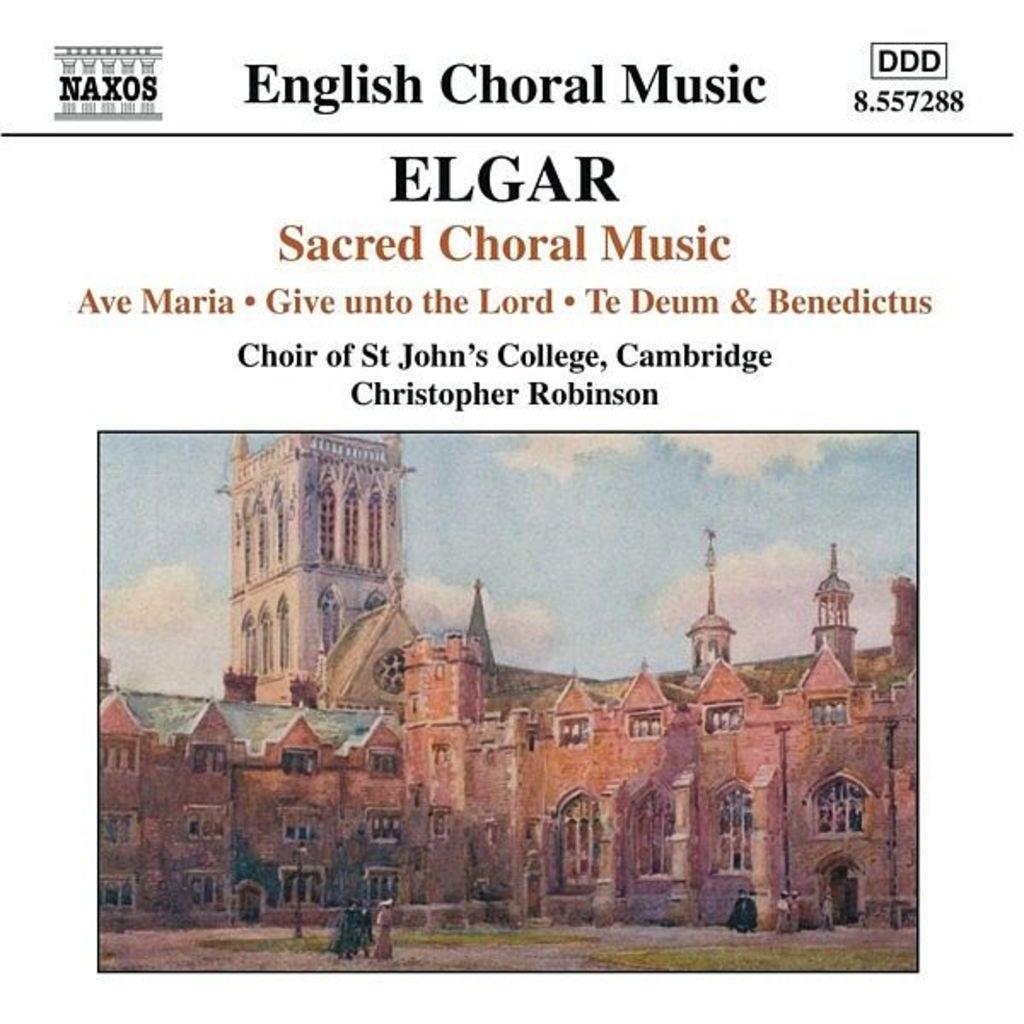How would you summarize this image in a sentence or two? In this image we can see a poster. There is some text and a drawing on a poster. There is a building in the image. There are few people in the image. There are two poles in the image. There is a blue and a slightly cloudy sky in the image. There are few plants in the image. 